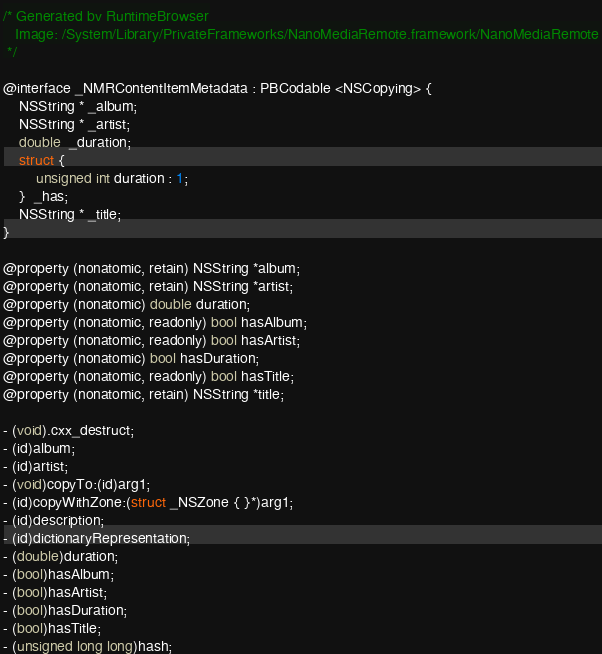<code> <loc_0><loc_0><loc_500><loc_500><_C_>/* Generated by RuntimeBrowser
   Image: /System/Library/PrivateFrameworks/NanoMediaRemote.framework/NanoMediaRemote
 */

@interface _NMRContentItemMetadata : PBCodable <NSCopying> {
    NSString * _album;
    NSString * _artist;
    double  _duration;
    struct { 
        unsigned int duration : 1; 
    }  _has;
    NSString * _title;
}

@property (nonatomic, retain) NSString *album;
@property (nonatomic, retain) NSString *artist;
@property (nonatomic) double duration;
@property (nonatomic, readonly) bool hasAlbum;
@property (nonatomic, readonly) bool hasArtist;
@property (nonatomic) bool hasDuration;
@property (nonatomic, readonly) bool hasTitle;
@property (nonatomic, retain) NSString *title;

- (void).cxx_destruct;
- (id)album;
- (id)artist;
- (void)copyTo:(id)arg1;
- (id)copyWithZone:(struct _NSZone { }*)arg1;
- (id)description;
- (id)dictionaryRepresentation;
- (double)duration;
- (bool)hasAlbum;
- (bool)hasArtist;
- (bool)hasDuration;
- (bool)hasTitle;
- (unsigned long long)hash;</code> 